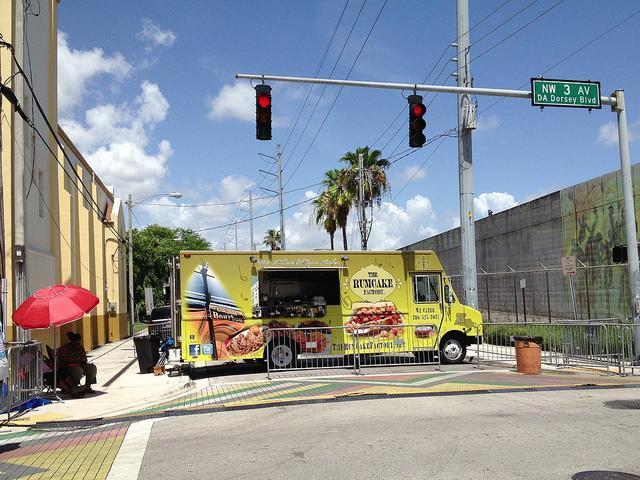How many boats are there?
Give a very brief answer. 0. 